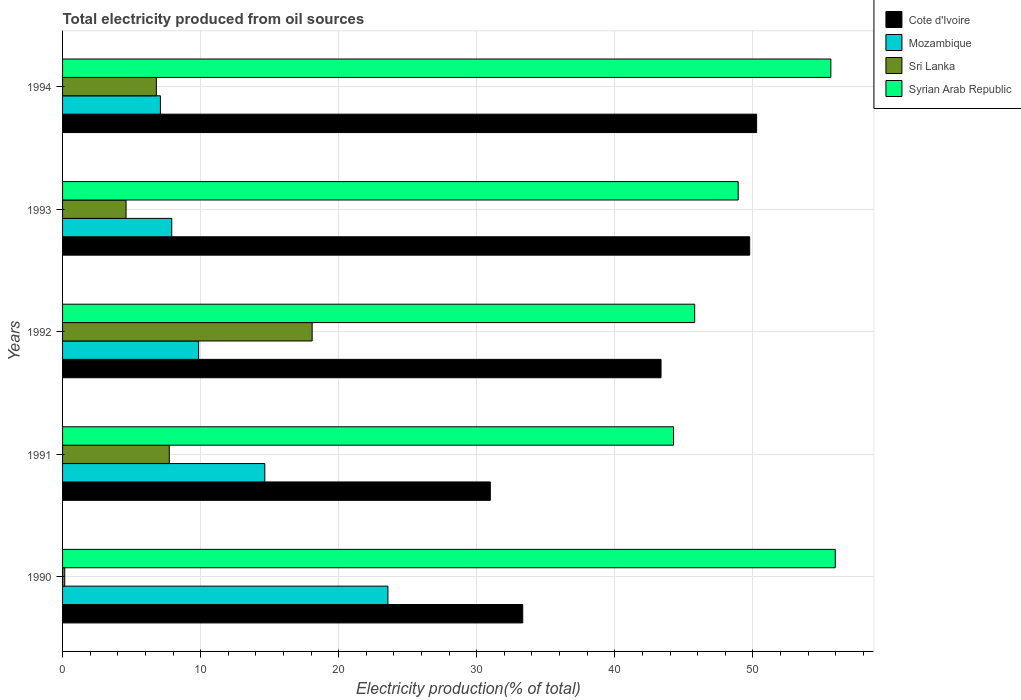Are the number of bars on each tick of the Y-axis equal?
Offer a terse response. Yes. How many bars are there on the 5th tick from the top?
Ensure brevity in your answer.  4. How many bars are there on the 2nd tick from the bottom?
Ensure brevity in your answer.  4. What is the label of the 1st group of bars from the top?
Offer a very short reply. 1994. In how many cases, is the number of bars for a given year not equal to the number of legend labels?
Provide a short and direct response. 0. What is the total electricity produced in Cote d'Ivoire in 1990?
Your answer should be very brief. 33.33. Across all years, what is the maximum total electricity produced in Cote d'Ivoire?
Provide a short and direct response. 50.28. Across all years, what is the minimum total electricity produced in Syrian Arab Republic?
Your response must be concise. 44.26. In which year was the total electricity produced in Cote d'Ivoire maximum?
Offer a terse response. 1994. In which year was the total electricity produced in Mozambique minimum?
Ensure brevity in your answer.  1994. What is the total total electricity produced in Syrian Arab Republic in the graph?
Provide a short and direct response. 250.61. What is the difference between the total electricity produced in Syrian Arab Republic in 1993 and that in 1994?
Make the answer very short. -6.71. What is the difference between the total electricity produced in Sri Lanka in 1992 and the total electricity produced in Syrian Arab Republic in 1991?
Give a very brief answer. -26.18. What is the average total electricity produced in Sri Lanka per year?
Offer a terse response. 7.47. In the year 1991, what is the difference between the total electricity produced in Syrian Arab Republic and total electricity produced in Cote d'Ivoire?
Give a very brief answer. 13.27. What is the ratio of the total electricity produced in Cote d'Ivoire in 1990 to that in 1992?
Ensure brevity in your answer.  0.77. Is the total electricity produced in Cote d'Ivoire in 1992 less than that in 1993?
Provide a short and direct response. Yes. What is the difference between the highest and the second highest total electricity produced in Cote d'Ivoire?
Provide a short and direct response. 0.5. What is the difference between the highest and the lowest total electricity produced in Syrian Arab Republic?
Provide a succinct answer. 11.72. In how many years, is the total electricity produced in Syrian Arab Republic greater than the average total electricity produced in Syrian Arab Republic taken over all years?
Make the answer very short. 2. Is the sum of the total electricity produced in Sri Lanka in 1992 and 1993 greater than the maximum total electricity produced in Cote d'Ivoire across all years?
Offer a terse response. No. What does the 2nd bar from the top in 1994 represents?
Your answer should be very brief. Sri Lanka. What does the 2nd bar from the bottom in 1992 represents?
Offer a terse response. Mozambique. How many bars are there?
Offer a very short reply. 20. Are all the bars in the graph horizontal?
Your answer should be very brief. Yes. Does the graph contain any zero values?
Keep it short and to the point. No. Where does the legend appear in the graph?
Make the answer very short. Top right. How many legend labels are there?
Keep it short and to the point. 4. How are the legend labels stacked?
Offer a very short reply. Vertical. What is the title of the graph?
Provide a short and direct response. Total electricity produced from oil sources. What is the Electricity production(% of total) of Cote d'Ivoire in 1990?
Offer a terse response. 33.33. What is the Electricity production(% of total) of Mozambique in 1990?
Make the answer very short. 23.57. What is the Electricity production(% of total) in Sri Lanka in 1990?
Provide a succinct answer. 0.16. What is the Electricity production(% of total) of Syrian Arab Republic in 1990?
Keep it short and to the point. 55.97. What is the Electricity production(% of total) of Cote d'Ivoire in 1991?
Your answer should be compact. 30.99. What is the Electricity production(% of total) of Mozambique in 1991?
Your answer should be compact. 14.65. What is the Electricity production(% of total) of Sri Lanka in 1991?
Provide a succinct answer. 7.73. What is the Electricity production(% of total) in Syrian Arab Republic in 1991?
Your answer should be very brief. 44.26. What is the Electricity production(% of total) of Cote d'Ivoire in 1992?
Your answer should be compact. 43.35. What is the Electricity production(% of total) of Mozambique in 1992?
Your answer should be compact. 9.86. What is the Electricity production(% of total) in Sri Lanka in 1992?
Offer a terse response. 18.08. What is the Electricity production(% of total) of Syrian Arab Republic in 1992?
Ensure brevity in your answer.  45.79. What is the Electricity production(% of total) in Cote d'Ivoire in 1993?
Keep it short and to the point. 49.77. What is the Electricity production(% of total) in Mozambique in 1993?
Your answer should be very brief. 7.91. What is the Electricity production(% of total) of Sri Lanka in 1993?
Give a very brief answer. 4.6. What is the Electricity production(% of total) of Syrian Arab Republic in 1993?
Your answer should be compact. 48.94. What is the Electricity production(% of total) of Cote d'Ivoire in 1994?
Offer a terse response. 50.28. What is the Electricity production(% of total) of Mozambique in 1994?
Provide a succinct answer. 7.09. What is the Electricity production(% of total) in Sri Lanka in 1994?
Ensure brevity in your answer.  6.79. What is the Electricity production(% of total) of Syrian Arab Republic in 1994?
Offer a very short reply. 55.65. Across all years, what is the maximum Electricity production(% of total) of Cote d'Ivoire?
Make the answer very short. 50.28. Across all years, what is the maximum Electricity production(% of total) of Mozambique?
Provide a short and direct response. 23.57. Across all years, what is the maximum Electricity production(% of total) in Sri Lanka?
Your answer should be compact. 18.08. Across all years, what is the maximum Electricity production(% of total) in Syrian Arab Republic?
Provide a succinct answer. 55.97. Across all years, what is the minimum Electricity production(% of total) of Cote d'Ivoire?
Keep it short and to the point. 30.99. Across all years, what is the minimum Electricity production(% of total) of Mozambique?
Your response must be concise. 7.09. Across all years, what is the minimum Electricity production(% of total) of Sri Lanka?
Provide a short and direct response. 0.16. Across all years, what is the minimum Electricity production(% of total) of Syrian Arab Republic?
Your answer should be compact. 44.26. What is the total Electricity production(% of total) in Cote d'Ivoire in the graph?
Offer a very short reply. 207.72. What is the total Electricity production(% of total) of Mozambique in the graph?
Your answer should be compact. 63.07. What is the total Electricity production(% of total) in Sri Lanka in the graph?
Keep it short and to the point. 37.36. What is the total Electricity production(% of total) in Syrian Arab Republic in the graph?
Offer a very short reply. 250.61. What is the difference between the Electricity production(% of total) in Cote d'Ivoire in 1990 and that in 1991?
Offer a terse response. 2.35. What is the difference between the Electricity production(% of total) in Mozambique in 1990 and that in 1991?
Your answer should be very brief. 8.92. What is the difference between the Electricity production(% of total) of Sri Lanka in 1990 and that in 1991?
Your response must be concise. -7.57. What is the difference between the Electricity production(% of total) in Syrian Arab Republic in 1990 and that in 1991?
Give a very brief answer. 11.72. What is the difference between the Electricity production(% of total) of Cote d'Ivoire in 1990 and that in 1992?
Your answer should be very brief. -10.02. What is the difference between the Electricity production(% of total) of Mozambique in 1990 and that in 1992?
Make the answer very short. 13.71. What is the difference between the Electricity production(% of total) in Sri Lanka in 1990 and that in 1992?
Give a very brief answer. -17.92. What is the difference between the Electricity production(% of total) in Syrian Arab Republic in 1990 and that in 1992?
Provide a succinct answer. 10.18. What is the difference between the Electricity production(% of total) of Cote d'Ivoire in 1990 and that in 1993?
Your answer should be very brief. -16.44. What is the difference between the Electricity production(% of total) of Mozambique in 1990 and that in 1993?
Offer a very short reply. 15.66. What is the difference between the Electricity production(% of total) in Sri Lanka in 1990 and that in 1993?
Your answer should be very brief. -4.44. What is the difference between the Electricity production(% of total) of Syrian Arab Republic in 1990 and that in 1993?
Offer a very short reply. 7.03. What is the difference between the Electricity production(% of total) in Cote d'Ivoire in 1990 and that in 1994?
Provide a succinct answer. -16.94. What is the difference between the Electricity production(% of total) in Mozambique in 1990 and that in 1994?
Give a very brief answer. 16.48. What is the difference between the Electricity production(% of total) in Sri Lanka in 1990 and that in 1994?
Your response must be concise. -6.63. What is the difference between the Electricity production(% of total) of Syrian Arab Republic in 1990 and that in 1994?
Give a very brief answer. 0.32. What is the difference between the Electricity production(% of total) in Cote d'Ivoire in 1991 and that in 1992?
Your response must be concise. -12.37. What is the difference between the Electricity production(% of total) in Mozambique in 1991 and that in 1992?
Make the answer very short. 4.79. What is the difference between the Electricity production(% of total) of Sri Lanka in 1991 and that in 1992?
Keep it short and to the point. -10.35. What is the difference between the Electricity production(% of total) of Syrian Arab Republic in 1991 and that in 1992?
Make the answer very short. -1.53. What is the difference between the Electricity production(% of total) in Cote d'Ivoire in 1991 and that in 1993?
Your answer should be compact. -18.79. What is the difference between the Electricity production(% of total) of Mozambique in 1991 and that in 1993?
Give a very brief answer. 6.74. What is the difference between the Electricity production(% of total) in Sri Lanka in 1991 and that in 1993?
Ensure brevity in your answer.  3.13. What is the difference between the Electricity production(% of total) of Syrian Arab Republic in 1991 and that in 1993?
Offer a very short reply. -4.68. What is the difference between the Electricity production(% of total) of Cote d'Ivoire in 1991 and that in 1994?
Your response must be concise. -19.29. What is the difference between the Electricity production(% of total) in Mozambique in 1991 and that in 1994?
Your answer should be compact. 7.56. What is the difference between the Electricity production(% of total) in Sri Lanka in 1991 and that in 1994?
Your answer should be very brief. 0.94. What is the difference between the Electricity production(% of total) of Syrian Arab Republic in 1991 and that in 1994?
Provide a succinct answer. -11.39. What is the difference between the Electricity production(% of total) in Cote d'Ivoire in 1992 and that in 1993?
Ensure brevity in your answer.  -6.42. What is the difference between the Electricity production(% of total) in Mozambique in 1992 and that in 1993?
Give a very brief answer. 1.95. What is the difference between the Electricity production(% of total) of Sri Lanka in 1992 and that in 1993?
Ensure brevity in your answer.  13.48. What is the difference between the Electricity production(% of total) in Syrian Arab Republic in 1992 and that in 1993?
Keep it short and to the point. -3.15. What is the difference between the Electricity production(% of total) in Cote d'Ivoire in 1992 and that in 1994?
Your answer should be compact. -6.92. What is the difference between the Electricity production(% of total) in Mozambique in 1992 and that in 1994?
Ensure brevity in your answer.  2.77. What is the difference between the Electricity production(% of total) in Sri Lanka in 1992 and that in 1994?
Provide a short and direct response. 11.29. What is the difference between the Electricity production(% of total) in Syrian Arab Republic in 1992 and that in 1994?
Provide a short and direct response. -9.86. What is the difference between the Electricity production(% of total) of Cote d'Ivoire in 1993 and that in 1994?
Keep it short and to the point. -0.5. What is the difference between the Electricity production(% of total) in Mozambique in 1993 and that in 1994?
Provide a short and direct response. 0.82. What is the difference between the Electricity production(% of total) in Sri Lanka in 1993 and that in 1994?
Your response must be concise. -2.19. What is the difference between the Electricity production(% of total) of Syrian Arab Republic in 1993 and that in 1994?
Offer a terse response. -6.71. What is the difference between the Electricity production(% of total) of Cote d'Ivoire in 1990 and the Electricity production(% of total) of Mozambique in 1991?
Your answer should be compact. 18.68. What is the difference between the Electricity production(% of total) of Cote d'Ivoire in 1990 and the Electricity production(% of total) of Sri Lanka in 1991?
Provide a short and direct response. 25.6. What is the difference between the Electricity production(% of total) of Cote d'Ivoire in 1990 and the Electricity production(% of total) of Syrian Arab Republic in 1991?
Your answer should be very brief. -10.92. What is the difference between the Electricity production(% of total) in Mozambique in 1990 and the Electricity production(% of total) in Sri Lanka in 1991?
Your response must be concise. 15.84. What is the difference between the Electricity production(% of total) in Mozambique in 1990 and the Electricity production(% of total) in Syrian Arab Republic in 1991?
Your answer should be compact. -20.69. What is the difference between the Electricity production(% of total) of Sri Lanka in 1990 and the Electricity production(% of total) of Syrian Arab Republic in 1991?
Your answer should be compact. -44.1. What is the difference between the Electricity production(% of total) of Cote d'Ivoire in 1990 and the Electricity production(% of total) of Mozambique in 1992?
Offer a terse response. 23.48. What is the difference between the Electricity production(% of total) of Cote d'Ivoire in 1990 and the Electricity production(% of total) of Sri Lanka in 1992?
Give a very brief answer. 15.25. What is the difference between the Electricity production(% of total) of Cote d'Ivoire in 1990 and the Electricity production(% of total) of Syrian Arab Republic in 1992?
Keep it short and to the point. -12.46. What is the difference between the Electricity production(% of total) of Mozambique in 1990 and the Electricity production(% of total) of Sri Lanka in 1992?
Make the answer very short. 5.49. What is the difference between the Electricity production(% of total) in Mozambique in 1990 and the Electricity production(% of total) in Syrian Arab Republic in 1992?
Ensure brevity in your answer.  -22.22. What is the difference between the Electricity production(% of total) in Sri Lanka in 1990 and the Electricity production(% of total) in Syrian Arab Republic in 1992?
Ensure brevity in your answer.  -45.63. What is the difference between the Electricity production(% of total) of Cote d'Ivoire in 1990 and the Electricity production(% of total) of Mozambique in 1993?
Ensure brevity in your answer.  25.43. What is the difference between the Electricity production(% of total) in Cote d'Ivoire in 1990 and the Electricity production(% of total) in Sri Lanka in 1993?
Give a very brief answer. 28.73. What is the difference between the Electricity production(% of total) of Cote d'Ivoire in 1990 and the Electricity production(% of total) of Syrian Arab Republic in 1993?
Provide a short and direct response. -15.61. What is the difference between the Electricity production(% of total) in Mozambique in 1990 and the Electricity production(% of total) in Sri Lanka in 1993?
Offer a terse response. 18.97. What is the difference between the Electricity production(% of total) in Mozambique in 1990 and the Electricity production(% of total) in Syrian Arab Republic in 1993?
Keep it short and to the point. -25.37. What is the difference between the Electricity production(% of total) of Sri Lanka in 1990 and the Electricity production(% of total) of Syrian Arab Republic in 1993?
Keep it short and to the point. -48.78. What is the difference between the Electricity production(% of total) of Cote d'Ivoire in 1990 and the Electricity production(% of total) of Mozambique in 1994?
Give a very brief answer. 26.24. What is the difference between the Electricity production(% of total) of Cote d'Ivoire in 1990 and the Electricity production(% of total) of Sri Lanka in 1994?
Your answer should be very brief. 26.54. What is the difference between the Electricity production(% of total) in Cote d'Ivoire in 1990 and the Electricity production(% of total) in Syrian Arab Republic in 1994?
Ensure brevity in your answer.  -22.32. What is the difference between the Electricity production(% of total) of Mozambique in 1990 and the Electricity production(% of total) of Sri Lanka in 1994?
Your answer should be compact. 16.78. What is the difference between the Electricity production(% of total) of Mozambique in 1990 and the Electricity production(% of total) of Syrian Arab Republic in 1994?
Provide a succinct answer. -32.08. What is the difference between the Electricity production(% of total) of Sri Lanka in 1990 and the Electricity production(% of total) of Syrian Arab Republic in 1994?
Make the answer very short. -55.49. What is the difference between the Electricity production(% of total) in Cote d'Ivoire in 1991 and the Electricity production(% of total) in Mozambique in 1992?
Your response must be concise. 21.13. What is the difference between the Electricity production(% of total) of Cote d'Ivoire in 1991 and the Electricity production(% of total) of Sri Lanka in 1992?
Ensure brevity in your answer.  12.91. What is the difference between the Electricity production(% of total) of Cote d'Ivoire in 1991 and the Electricity production(% of total) of Syrian Arab Republic in 1992?
Make the answer very short. -14.8. What is the difference between the Electricity production(% of total) in Mozambique in 1991 and the Electricity production(% of total) in Sri Lanka in 1992?
Offer a terse response. -3.43. What is the difference between the Electricity production(% of total) in Mozambique in 1991 and the Electricity production(% of total) in Syrian Arab Republic in 1992?
Your answer should be very brief. -31.14. What is the difference between the Electricity production(% of total) of Sri Lanka in 1991 and the Electricity production(% of total) of Syrian Arab Republic in 1992?
Provide a succinct answer. -38.06. What is the difference between the Electricity production(% of total) of Cote d'Ivoire in 1991 and the Electricity production(% of total) of Mozambique in 1993?
Your answer should be very brief. 23.08. What is the difference between the Electricity production(% of total) of Cote d'Ivoire in 1991 and the Electricity production(% of total) of Sri Lanka in 1993?
Your response must be concise. 26.39. What is the difference between the Electricity production(% of total) in Cote d'Ivoire in 1991 and the Electricity production(% of total) in Syrian Arab Republic in 1993?
Offer a very short reply. -17.95. What is the difference between the Electricity production(% of total) in Mozambique in 1991 and the Electricity production(% of total) in Sri Lanka in 1993?
Provide a short and direct response. 10.05. What is the difference between the Electricity production(% of total) of Mozambique in 1991 and the Electricity production(% of total) of Syrian Arab Republic in 1993?
Your answer should be compact. -34.29. What is the difference between the Electricity production(% of total) of Sri Lanka in 1991 and the Electricity production(% of total) of Syrian Arab Republic in 1993?
Offer a terse response. -41.21. What is the difference between the Electricity production(% of total) in Cote d'Ivoire in 1991 and the Electricity production(% of total) in Mozambique in 1994?
Your answer should be very brief. 23.9. What is the difference between the Electricity production(% of total) in Cote d'Ivoire in 1991 and the Electricity production(% of total) in Sri Lanka in 1994?
Your answer should be compact. 24.19. What is the difference between the Electricity production(% of total) in Cote d'Ivoire in 1991 and the Electricity production(% of total) in Syrian Arab Republic in 1994?
Your response must be concise. -24.67. What is the difference between the Electricity production(% of total) of Mozambique in 1991 and the Electricity production(% of total) of Sri Lanka in 1994?
Keep it short and to the point. 7.86. What is the difference between the Electricity production(% of total) in Mozambique in 1991 and the Electricity production(% of total) in Syrian Arab Republic in 1994?
Offer a terse response. -41. What is the difference between the Electricity production(% of total) in Sri Lanka in 1991 and the Electricity production(% of total) in Syrian Arab Republic in 1994?
Ensure brevity in your answer.  -47.92. What is the difference between the Electricity production(% of total) of Cote d'Ivoire in 1992 and the Electricity production(% of total) of Mozambique in 1993?
Your answer should be compact. 35.44. What is the difference between the Electricity production(% of total) of Cote d'Ivoire in 1992 and the Electricity production(% of total) of Sri Lanka in 1993?
Make the answer very short. 38.75. What is the difference between the Electricity production(% of total) of Cote d'Ivoire in 1992 and the Electricity production(% of total) of Syrian Arab Republic in 1993?
Make the answer very short. -5.59. What is the difference between the Electricity production(% of total) of Mozambique in 1992 and the Electricity production(% of total) of Sri Lanka in 1993?
Give a very brief answer. 5.26. What is the difference between the Electricity production(% of total) in Mozambique in 1992 and the Electricity production(% of total) in Syrian Arab Republic in 1993?
Ensure brevity in your answer.  -39.08. What is the difference between the Electricity production(% of total) in Sri Lanka in 1992 and the Electricity production(% of total) in Syrian Arab Republic in 1993?
Your answer should be very brief. -30.86. What is the difference between the Electricity production(% of total) of Cote d'Ivoire in 1992 and the Electricity production(% of total) of Mozambique in 1994?
Offer a very short reply. 36.26. What is the difference between the Electricity production(% of total) in Cote d'Ivoire in 1992 and the Electricity production(% of total) in Sri Lanka in 1994?
Your answer should be very brief. 36.56. What is the difference between the Electricity production(% of total) of Cote d'Ivoire in 1992 and the Electricity production(% of total) of Syrian Arab Republic in 1994?
Provide a short and direct response. -12.3. What is the difference between the Electricity production(% of total) of Mozambique in 1992 and the Electricity production(% of total) of Sri Lanka in 1994?
Your answer should be very brief. 3.06. What is the difference between the Electricity production(% of total) in Mozambique in 1992 and the Electricity production(% of total) in Syrian Arab Republic in 1994?
Your answer should be very brief. -45.8. What is the difference between the Electricity production(% of total) in Sri Lanka in 1992 and the Electricity production(% of total) in Syrian Arab Republic in 1994?
Provide a succinct answer. -37.57. What is the difference between the Electricity production(% of total) in Cote d'Ivoire in 1993 and the Electricity production(% of total) in Mozambique in 1994?
Provide a short and direct response. 42.68. What is the difference between the Electricity production(% of total) in Cote d'Ivoire in 1993 and the Electricity production(% of total) in Sri Lanka in 1994?
Your response must be concise. 42.98. What is the difference between the Electricity production(% of total) in Cote d'Ivoire in 1993 and the Electricity production(% of total) in Syrian Arab Republic in 1994?
Make the answer very short. -5.88. What is the difference between the Electricity production(% of total) in Mozambique in 1993 and the Electricity production(% of total) in Sri Lanka in 1994?
Provide a short and direct response. 1.12. What is the difference between the Electricity production(% of total) of Mozambique in 1993 and the Electricity production(% of total) of Syrian Arab Republic in 1994?
Make the answer very short. -47.74. What is the difference between the Electricity production(% of total) in Sri Lanka in 1993 and the Electricity production(% of total) in Syrian Arab Republic in 1994?
Make the answer very short. -51.05. What is the average Electricity production(% of total) of Cote d'Ivoire per year?
Provide a succinct answer. 41.54. What is the average Electricity production(% of total) of Mozambique per year?
Provide a succinct answer. 12.61. What is the average Electricity production(% of total) in Sri Lanka per year?
Give a very brief answer. 7.47. What is the average Electricity production(% of total) in Syrian Arab Republic per year?
Offer a terse response. 50.12. In the year 1990, what is the difference between the Electricity production(% of total) of Cote d'Ivoire and Electricity production(% of total) of Mozambique?
Keep it short and to the point. 9.77. In the year 1990, what is the difference between the Electricity production(% of total) of Cote d'Ivoire and Electricity production(% of total) of Sri Lanka?
Offer a terse response. 33.17. In the year 1990, what is the difference between the Electricity production(% of total) in Cote d'Ivoire and Electricity production(% of total) in Syrian Arab Republic?
Your answer should be compact. -22.64. In the year 1990, what is the difference between the Electricity production(% of total) in Mozambique and Electricity production(% of total) in Sri Lanka?
Your answer should be very brief. 23.41. In the year 1990, what is the difference between the Electricity production(% of total) in Mozambique and Electricity production(% of total) in Syrian Arab Republic?
Offer a very short reply. -32.4. In the year 1990, what is the difference between the Electricity production(% of total) of Sri Lanka and Electricity production(% of total) of Syrian Arab Republic?
Your answer should be very brief. -55.81. In the year 1991, what is the difference between the Electricity production(% of total) in Cote d'Ivoire and Electricity production(% of total) in Mozambique?
Your response must be concise. 16.34. In the year 1991, what is the difference between the Electricity production(% of total) in Cote d'Ivoire and Electricity production(% of total) in Sri Lanka?
Keep it short and to the point. 23.26. In the year 1991, what is the difference between the Electricity production(% of total) in Cote d'Ivoire and Electricity production(% of total) in Syrian Arab Republic?
Your response must be concise. -13.27. In the year 1991, what is the difference between the Electricity production(% of total) of Mozambique and Electricity production(% of total) of Sri Lanka?
Offer a terse response. 6.92. In the year 1991, what is the difference between the Electricity production(% of total) of Mozambique and Electricity production(% of total) of Syrian Arab Republic?
Your answer should be very brief. -29.61. In the year 1991, what is the difference between the Electricity production(% of total) of Sri Lanka and Electricity production(% of total) of Syrian Arab Republic?
Your response must be concise. -36.53. In the year 1992, what is the difference between the Electricity production(% of total) of Cote d'Ivoire and Electricity production(% of total) of Mozambique?
Your answer should be compact. 33.5. In the year 1992, what is the difference between the Electricity production(% of total) of Cote d'Ivoire and Electricity production(% of total) of Sri Lanka?
Ensure brevity in your answer.  25.27. In the year 1992, what is the difference between the Electricity production(% of total) of Cote d'Ivoire and Electricity production(% of total) of Syrian Arab Republic?
Offer a terse response. -2.44. In the year 1992, what is the difference between the Electricity production(% of total) in Mozambique and Electricity production(% of total) in Sri Lanka?
Give a very brief answer. -8.22. In the year 1992, what is the difference between the Electricity production(% of total) of Mozambique and Electricity production(% of total) of Syrian Arab Republic?
Keep it short and to the point. -35.93. In the year 1992, what is the difference between the Electricity production(% of total) in Sri Lanka and Electricity production(% of total) in Syrian Arab Republic?
Provide a short and direct response. -27.71. In the year 1993, what is the difference between the Electricity production(% of total) of Cote d'Ivoire and Electricity production(% of total) of Mozambique?
Keep it short and to the point. 41.86. In the year 1993, what is the difference between the Electricity production(% of total) of Cote d'Ivoire and Electricity production(% of total) of Sri Lanka?
Your answer should be very brief. 45.17. In the year 1993, what is the difference between the Electricity production(% of total) of Cote d'Ivoire and Electricity production(% of total) of Syrian Arab Republic?
Give a very brief answer. 0.83. In the year 1993, what is the difference between the Electricity production(% of total) of Mozambique and Electricity production(% of total) of Sri Lanka?
Your response must be concise. 3.31. In the year 1993, what is the difference between the Electricity production(% of total) in Mozambique and Electricity production(% of total) in Syrian Arab Republic?
Your response must be concise. -41.03. In the year 1993, what is the difference between the Electricity production(% of total) in Sri Lanka and Electricity production(% of total) in Syrian Arab Republic?
Your response must be concise. -44.34. In the year 1994, what is the difference between the Electricity production(% of total) of Cote d'Ivoire and Electricity production(% of total) of Mozambique?
Provide a succinct answer. 43.19. In the year 1994, what is the difference between the Electricity production(% of total) in Cote d'Ivoire and Electricity production(% of total) in Sri Lanka?
Keep it short and to the point. 43.48. In the year 1994, what is the difference between the Electricity production(% of total) in Cote d'Ivoire and Electricity production(% of total) in Syrian Arab Republic?
Your answer should be compact. -5.38. In the year 1994, what is the difference between the Electricity production(% of total) of Mozambique and Electricity production(% of total) of Sri Lanka?
Your answer should be very brief. 0.3. In the year 1994, what is the difference between the Electricity production(% of total) in Mozambique and Electricity production(% of total) in Syrian Arab Republic?
Provide a short and direct response. -48.56. In the year 1994, what is the difference between the Electricity production(% of total) of Sri Lanka and Electricity production(% of total) of Syrian Arab Republic?
Ensure brevity in your answer.  -48.86. What is the ratio of the Electricity production(% of total) of Cote d'Ivoire in 1990 to that in 1991?
Your answer should be compact. 1.08. What is the ratio of the Electricity production(% of total) in Mozambique in 1990 to that in 1991?
Ensure brevity in your answer.  1.61. What is the ratio of the Electricity production(% of total) of Sri Lanka in 1990 to that in 1991?
Offer a terse response. 0.02. What is the ratio of the Electricity production(% of total) in Syrian Arab Republic in 1990 to that in 1991?
Your answer should be very brief. 1.26. What is the ratio of the Electricity production(% of total) in Cote d'Ivoire in 1990 to that in 1992?
Keep it short and to the point. 0.77. What is the ratio of the Electricity production(% of total) in Mozambique in 1990 to that in 1992?
Make the answer very short. 2.39. What is the ratio of the Electricity production(% of total) of Sri Lanka in 1990 to that in 1992?
Give a very brief answer. 0.01. What is the ratio of the Electricity production(% of total) in Syrian Arab Republic in 1990 to that in 1992?
Your response must be concise. 1.22. What is the ratio of the Electricity production(% of total) of Cote d'Ivoire in 1990 to that in 1993?
Make the answer very short. 0.67. What is the ratio of the Electricity production(% of total) in Mozambique in 1990 to that in 1993?
Ensure brevity in your answer.  2.98. What is the ratio of the Electricity production(% of total) in Sri Lanka in 1990 to that in 1993?
Give a very brief answer. 0.03. What is the ratio of the Electricity production(% of total) in Syrian Arab Republic in 1990 to that in 1993?
Your answer should be compact. 1.14. What is the ratio of the Electricity production(% of total) in Cote d'Ivoire in 1990 to that in 1994?
Provide a succinct answer. 0.66. What is the ratio of the Electricity production(% of total) of Mozambique in 1990 to that in 1994?
Your response must be concise. 3.32. What is the ratio of the Electricity production(% of total) in Sri Lanka in 1990 to that in 1994?
Provide a succinct answer. 0.02. What is the ratio of the Electricity production(% of total) in Cote d'Ivoire in 1991 to that in 1992?
Ensure brevity in your answer.  0.71. What is the ratio of the Electricity production(% of total) of Mozambique in 1991 to that in 1992?
Offer a terse response. 1.49. What is the ratio of the Electricity production(% of total) in Sri Lanka in 1991 to that in 1992?
Provide a succinct answer. 0.43. What is the ratio of the Electricity production(% of total) in Syrian Arab Republic in 1991 to that in 1992?
Your answer should be compact. 0.97. What is the ratio of the Electricity production(% of total) in Cote d'Ivoire in 1991 to that in 1993?
Ensure brevity in your answer.  0.62. What is the ratio of the Electricity production(% of total) in Mozambique in 1991 to that in 1993?
Offer a terse response. 1.85. What is the ratio of the Electricity production(% of total) in Sri Lanka in 1991 to that in 1993?
Give a very brief answer. 1.68. What is the ratio of the Electricity production(% of total) in Syrian Arab Republic in 1991 to that in 1993?
Your response must be concise. 0.9. What is the ratio of the Electricity production(% of total) of Cote d'Ivoire in 1991 to that in 1994?
Provide a succinct answer. 0.62. What is the ratio of the Electricity production(% of total) of Mozambique in 1991 to that in 1994?
Make the answer very short. 2.07. What is the ratio of the Electricity production(% of total) in Sri Lanka in 1991 to that in 1994?
Offer a very short reply. 1.14. What is the ratio of the Electricity production(% of total) in Syrian Arab Republic in 1991 to that in 1994?
Ensure brevity in your answer.  0.8. What is the ratio of the Electricity production(% of total) of Cote d'Ivoire in 1992 to that in 1993?
Offer a very short reply. 0.87. What is the ratio of the Electricity production(% of total) of Mozambique in 1992 to that in 1993?
Offer a very short reply. 1.25. What is the ratio of the Electricity production(% of total) in Sri Lanka in 1992 to that in 1993?
Make the answer very short. 3.93. What is the ratio of the Electricity production(% of total) of Syrian Arab Republic in 1992 to that in 1993?
Keep it short and to the point. 0.94. What is the ratio of the Electricity production(% of total) of Cote d'Ivoire in 1992 to that in 1994?
Offer a terse response. 0.86. What is the ratio of the Electricity production(% of total) in Mozambique in 1992 to that in 1994?
Make the answer very short. 1.39. What is the ratio of the Electricity production(% of total) of Sri Lanka in 1992 to that in 1994?
Keep it short and to the point. 2.66. What is the ratio of the Electricity production(% of total) in Syrian Arab Republic in 1992 to that in 1994?
Your answer should be very brief. 0.82. What is the ratio of the Electricity production(% of total) of Cote d'Ivoire in 1993 to that in 1994?
Provide a short and direct response. 0.99. What is the ratio of the Electricity production(% of total) in Mozambique in 1993 to that in 1994?
Give a very brief answer. 1.12. What is the ratio of the Electricity production(% of total) in Sri Lanka in 1993 to that in 1994?
Offer a very short reply. 0.68. What is the ratio of the Electricity production(% of total) of Syrian Arab Republic in 1993 to that in 1994?
Give a very brief answer. 0.88. What is the difference between the highest and the second highest Electricity production(% of total) in Cote d'Ivoire?
Provide a succinct answer. 0.5. What is the difference between the highest and the second highest Electricity production(% of total) in Mozambique?
Your response must be concise. 8.92. What is the difference between the highest and the second highest Electricity production(% of total) in Sri Lanka?
Keep it short and to the point. 10.35. What is the difference between the highest and the second highest Electricity production(% of total) of Syrian Arab Republic?
Your answer should be compact. 0.32. What is the difference between the highest and the lowest Electricity production(% of total) of Cote d'Ivoire?
Ensure brevity in your answer.  19.29. What is the difference between the highest and the lowest Electricity production(% of total) in Mozambique?
Keep it short and to the point. 16.48. What is the difference between the highest and the lowest Electricity production(% of total) of Sri Lanka?
Keep it short and to the point. 17.92. What is the difference between the highest and the lowest Electricity production(% of total) of Syrian Arab Republic?
Make the answer very short. 11.72. 